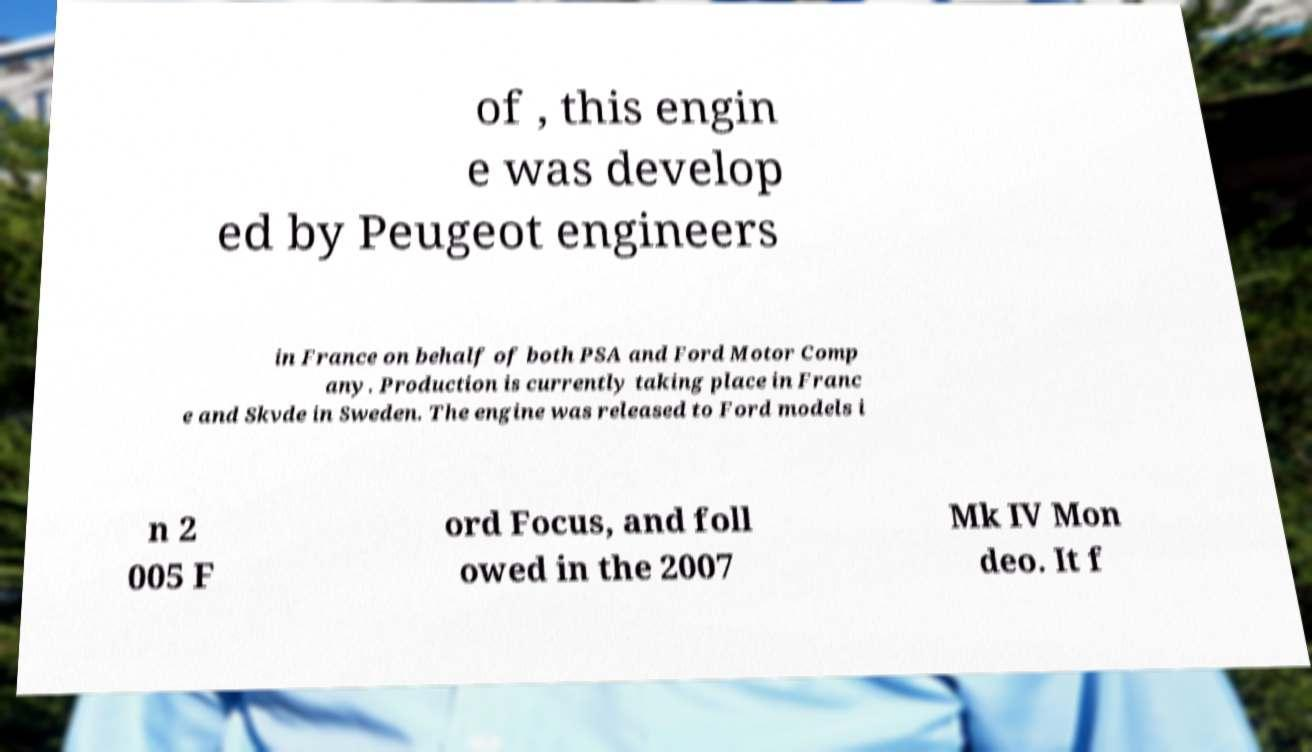What messages or text are displayed in this image? I need them in a readable, typed format. of , this engin e was develop ed by Peugeot engineers in France on behalf of both PSA and Ford Motor Comp any. Production is currently taking place in Franc e and Skvde in Sweden. The engine was released to Ford models i n 2 005 F ord Focus, and foll owed in the 2007 Mk IV Mon deo. It f 